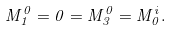Convert formula to latex. <formula><loc_0><loc_0><loc_500><loc_500>M ^ { 0 } _ { 1 } = 0 = M ^ { 0 } _ { 3 } = M ^ { i } _ { 0 } .</formula> 